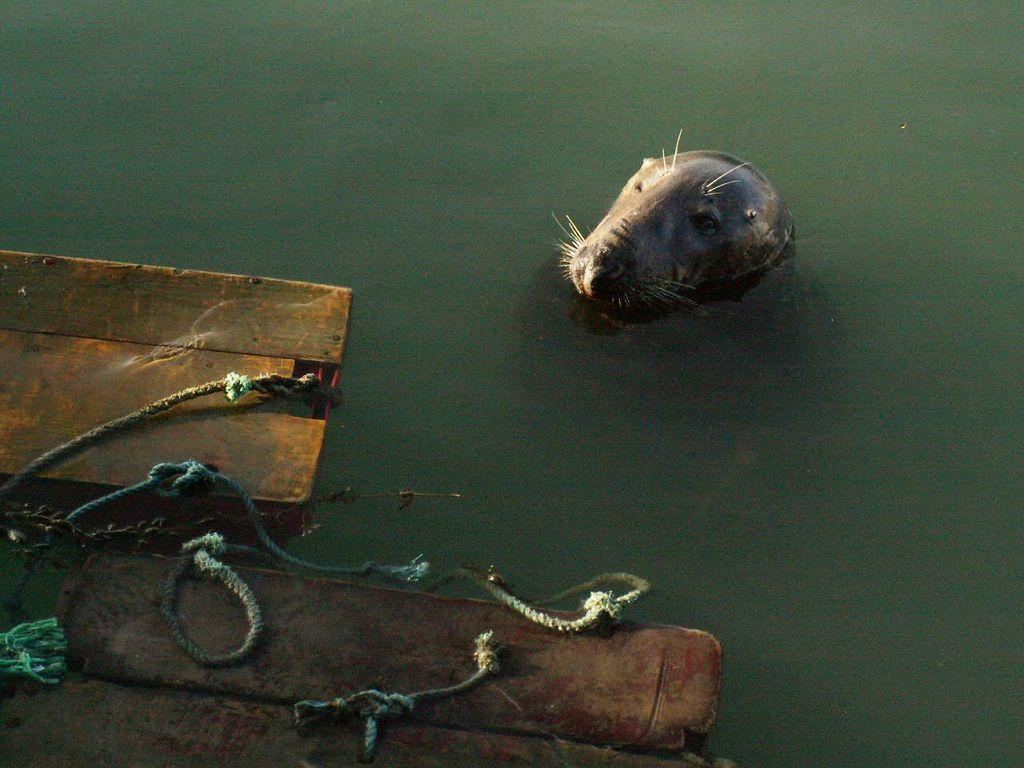What objects are made of wood and have ropes attached to them in the image? There are wooden boards with ropes in the image. What is the state of the wooden boards in the image? The wooden boards are floating on the water. What type of animal can be seen in the water in the image? There is a sea lion in the water. What is the color of the water in the image? The water is green in color. What type of paper is being used by the coach to calm the nerves of the players in the image? There is no paper, coach, or mention of nerves in the image; it features wooden boards, ropes, a sea lion, and green water. 